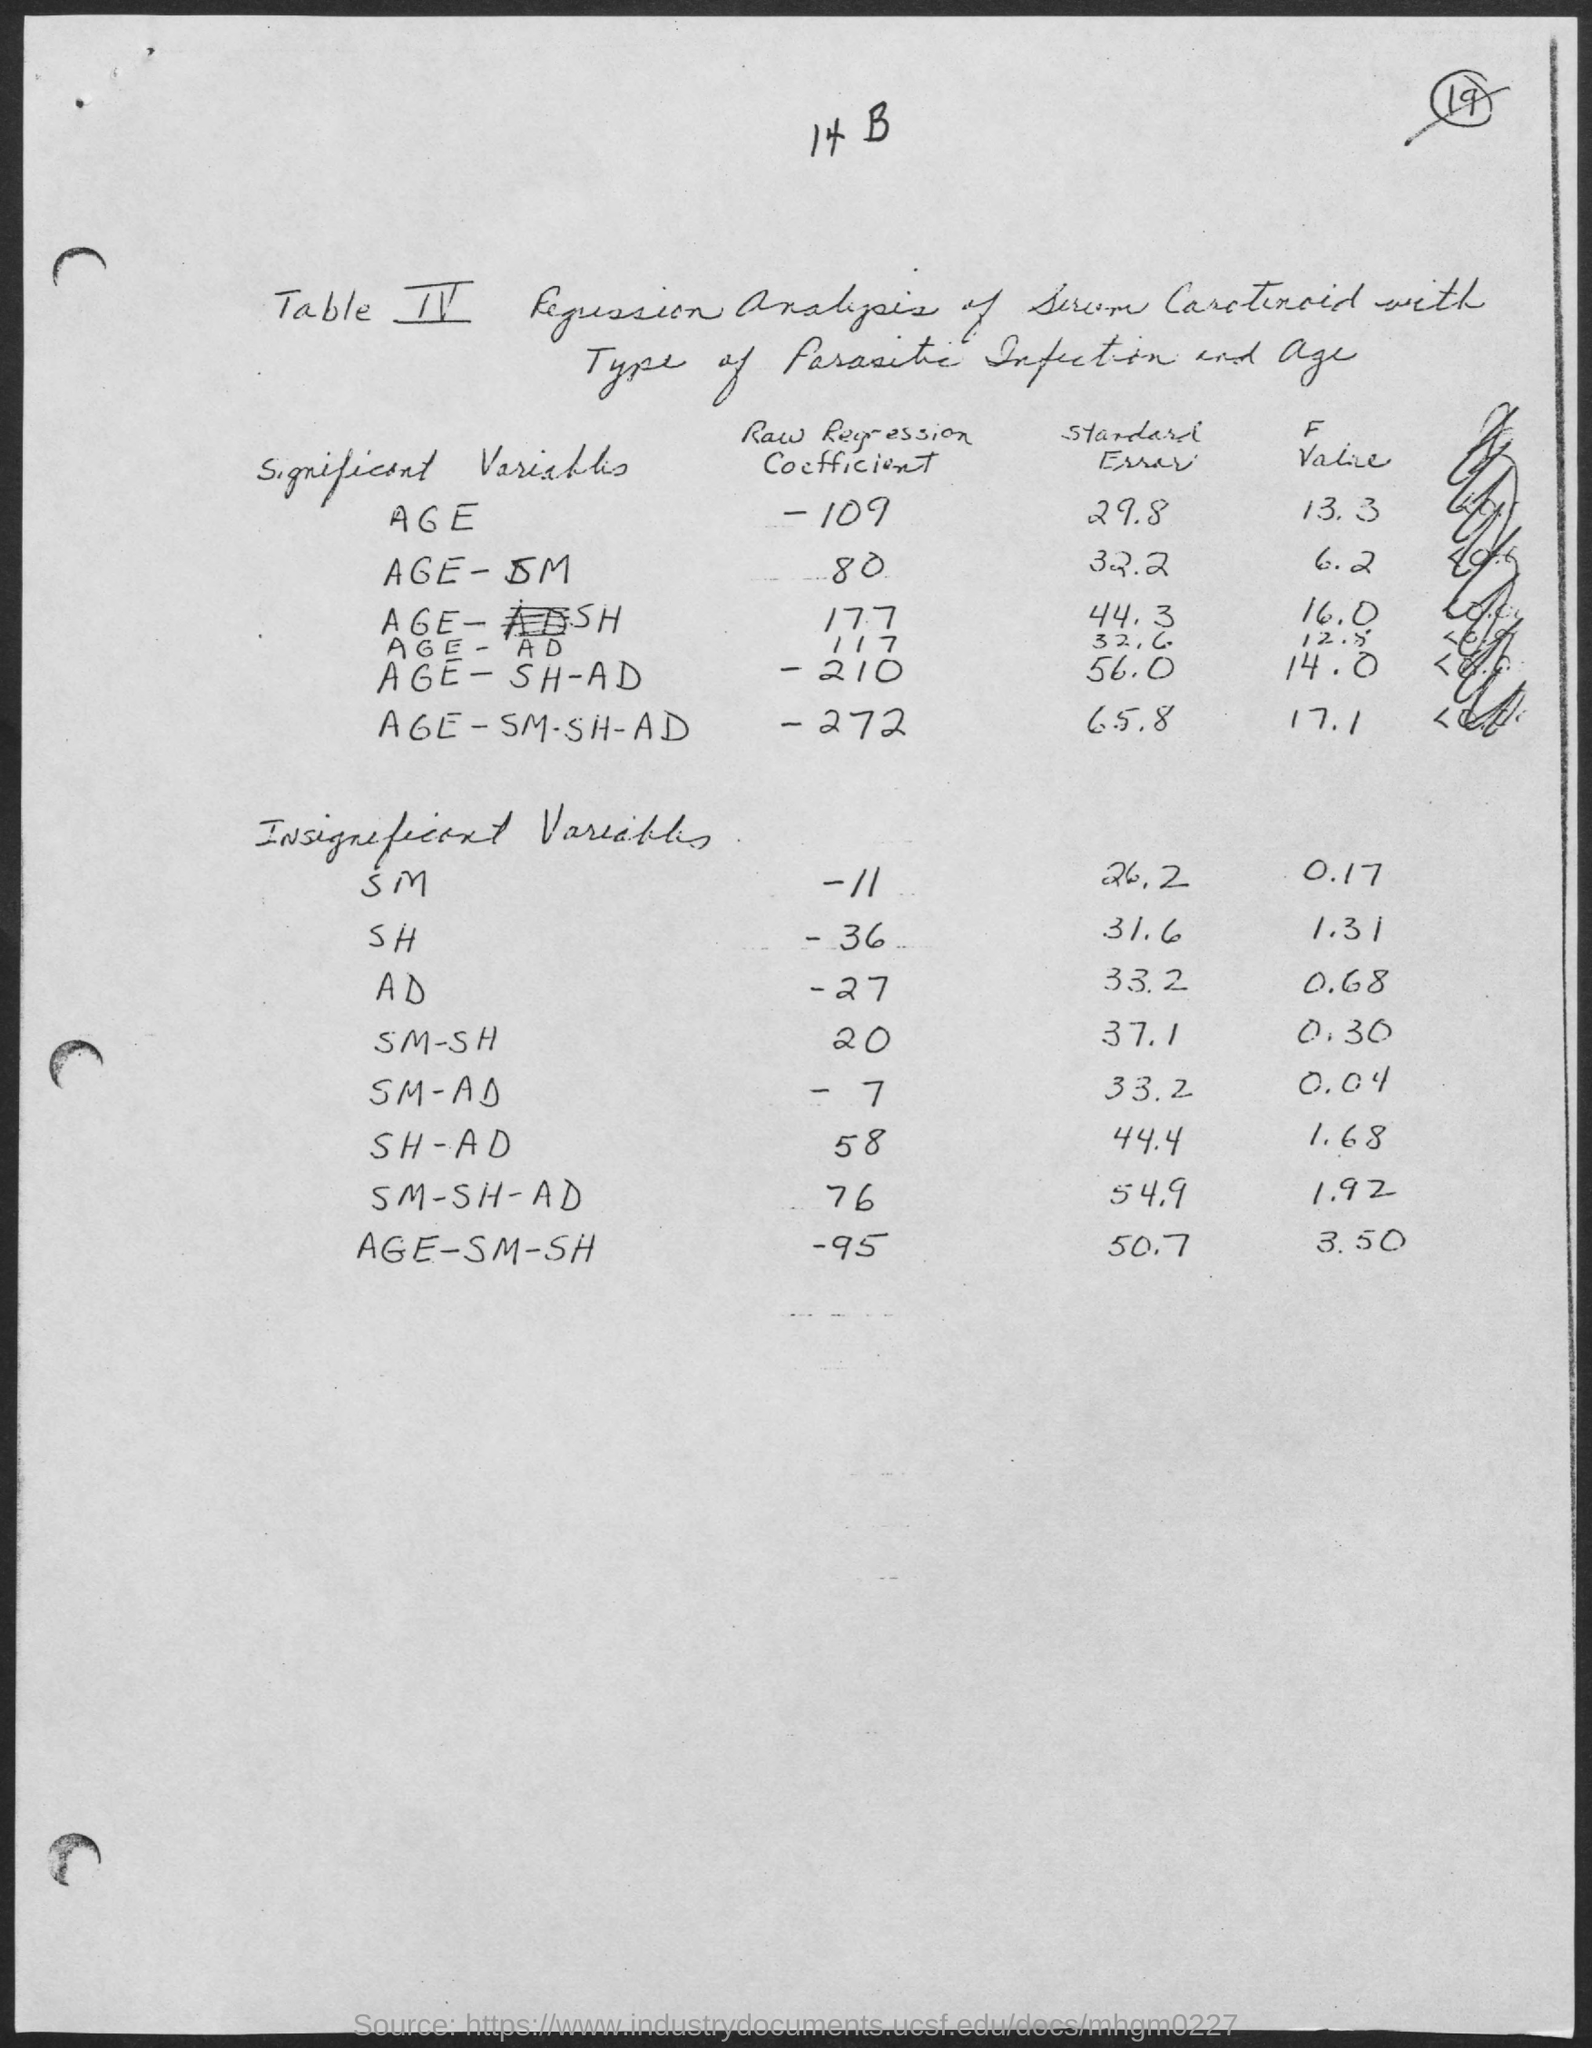What is the Raw Regression Coefficient for Age?
Provide a short and direct response. -109. What is the Raw Regression Coefficient for Age-SM?
Your answer should be very brief. 80. What is the Raw Regression Coefficient for Age-SH?
Make the answer very short. 177. What is the Raw Regression Coefficient for Age-AD?
Keep it short and to the point. 117. What is the Raw Regression Coefficient for Age-SH-AD?
Provide a short and direct response. 210. What is the Raw Regression Coefficient for Age-SM-SH-AD?
Your response must be concise. -272. What is the Standard Error for Age?
Give a very brief answer. 29.8. What is the Standard Error for Age-SM?
Your answer should be compact. 32.2. What is the Standard Error for Age-SH?
Give a very brief answer. 44.3. What is the Standard Error for Age-AD
Your answer should be compact. 32.6. 